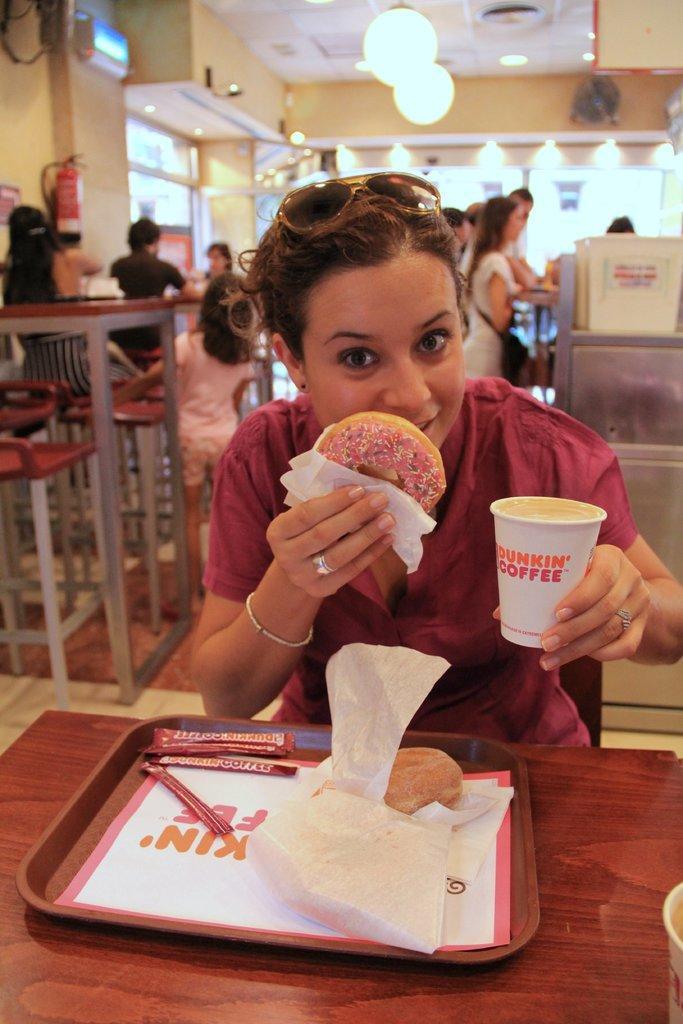Please provide a concise description of this image. In this image a woman is sitting and holding a doughnut one hand and coffee on the other hand. This is a table where a tray and some other object is placed on it. At background I can see people sitting and standing. This is a lamp which is changed through the roof top. And this seems like an restaurant. 